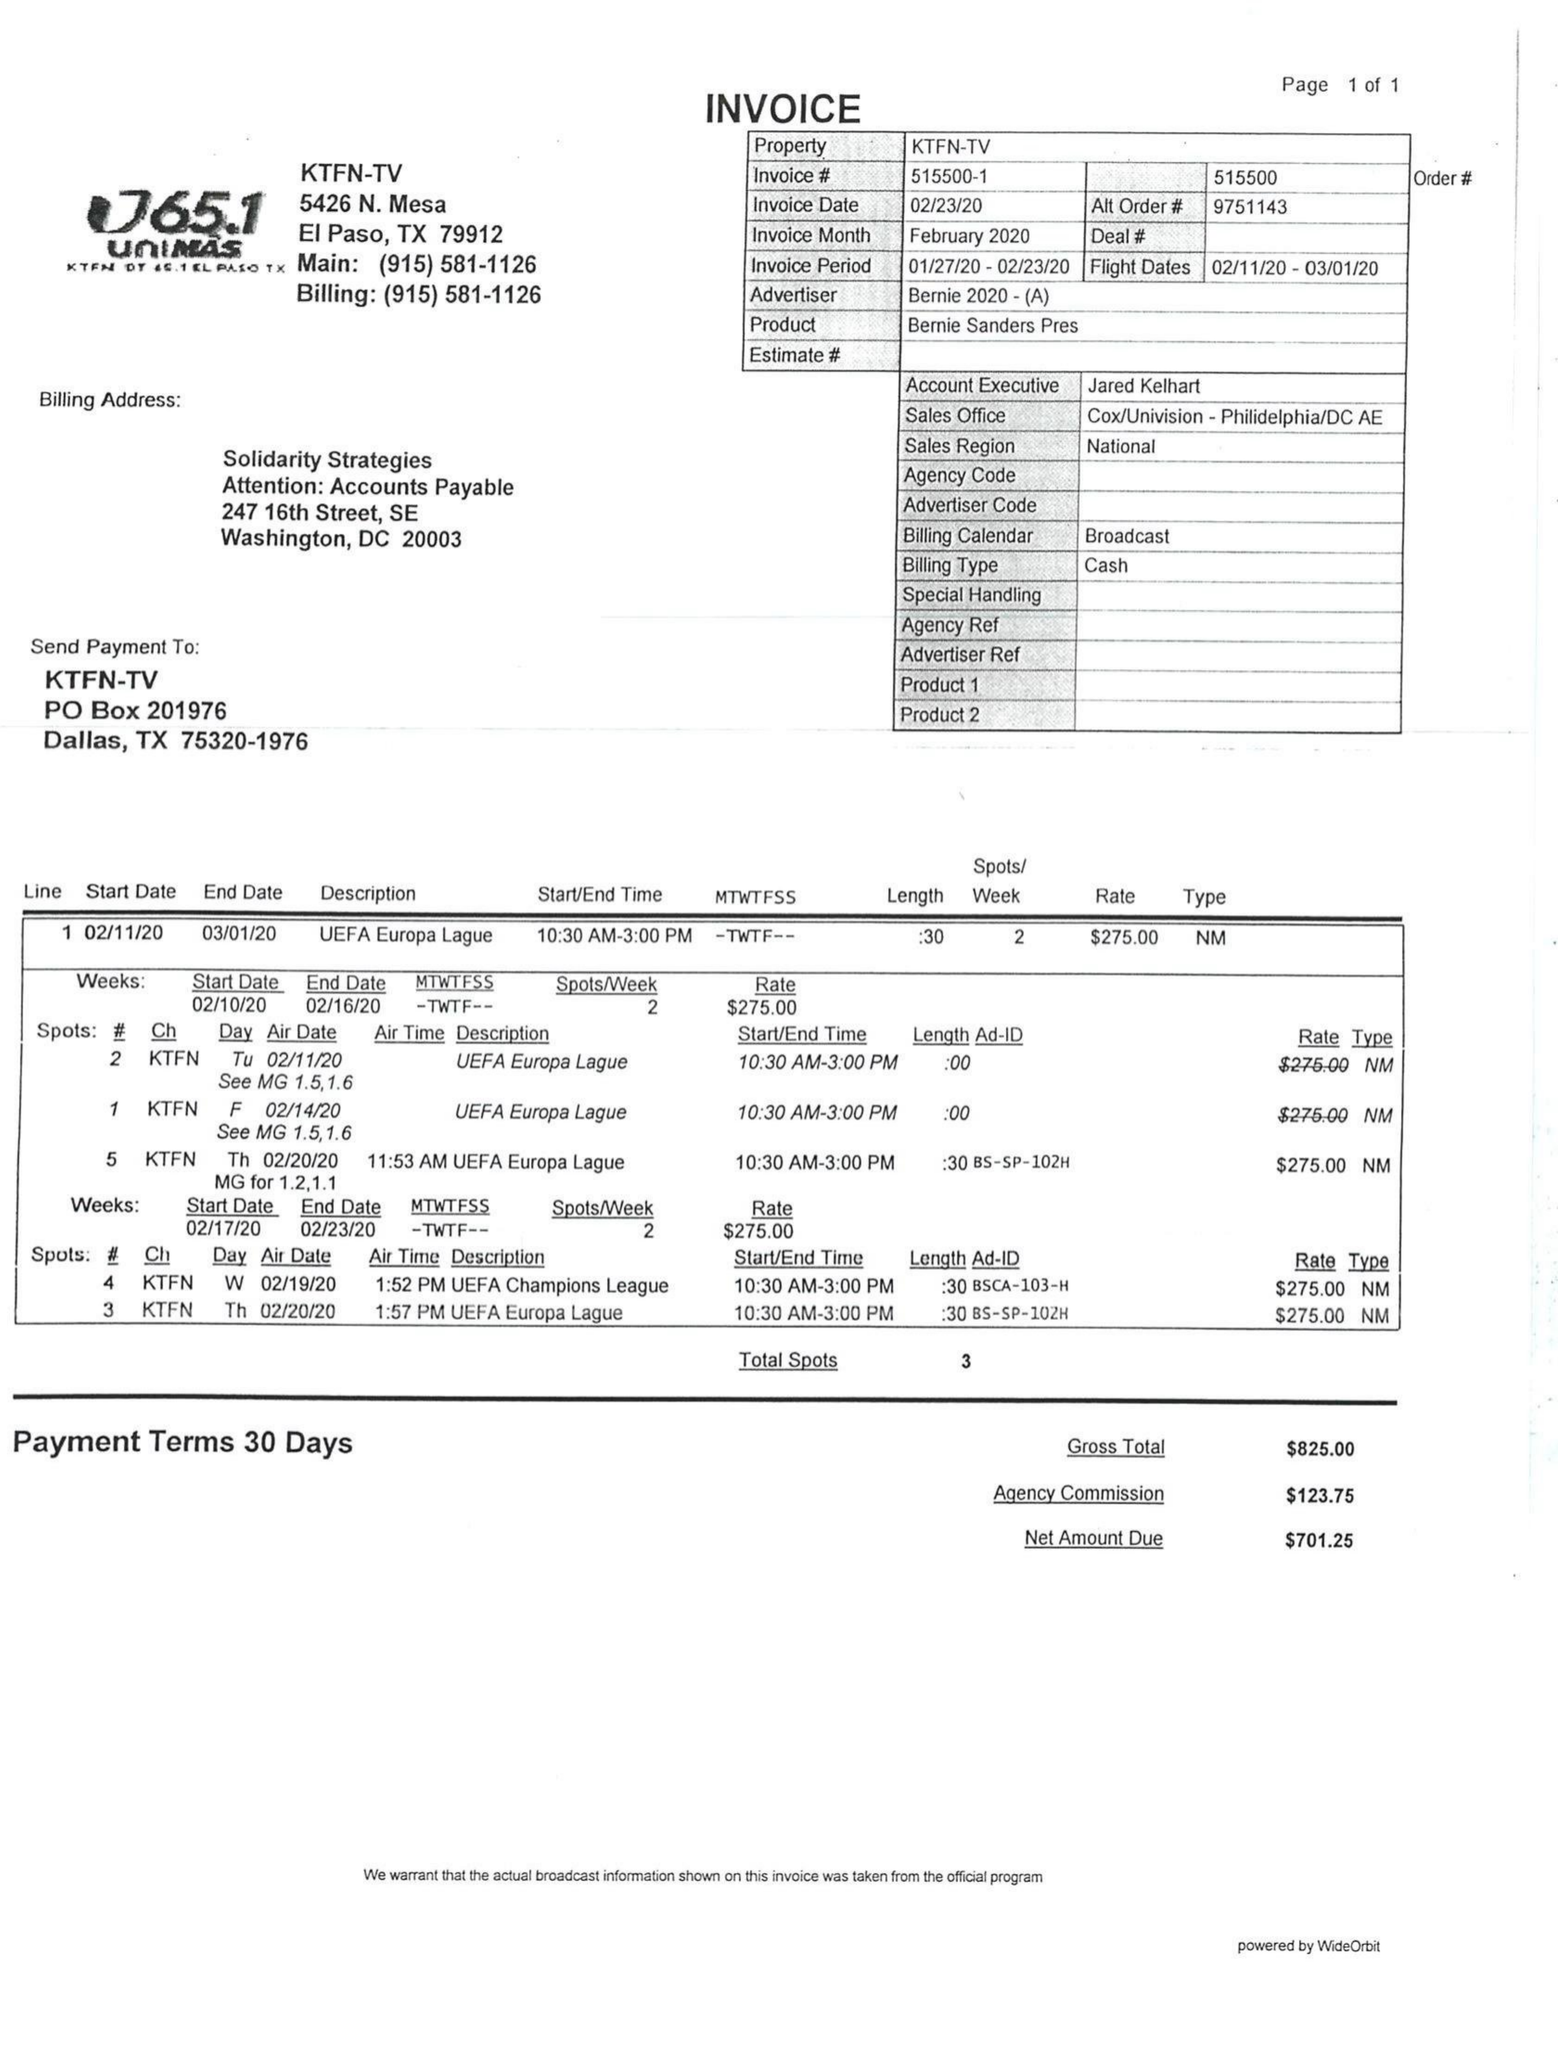What is the value for the gross_amount?
Answer the question using a single word or phrase. 825.00 